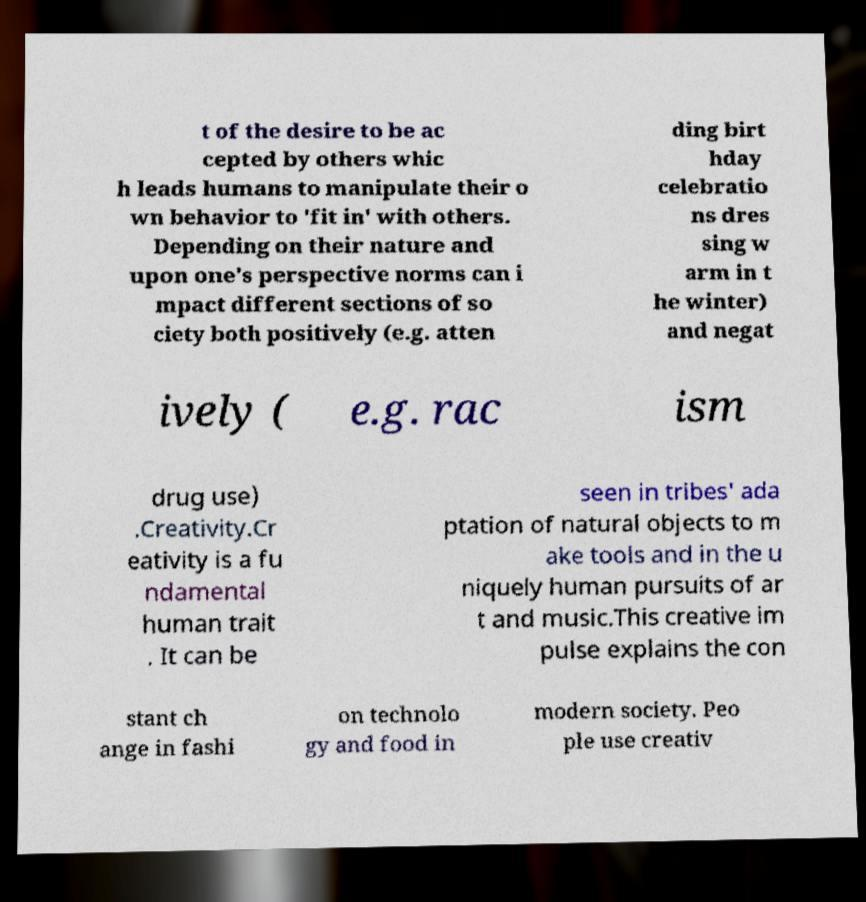There's text embedded in this image that I need extracted. Can you transcribe it verbatim? t of the desire to be ac cepted by others whic h leads humans to manipulate their o wn behavior to 'fit in' with others. Depending on their nature and upon one's perspective norms can i mpact different sections of so ciety both positively (e.g. atten ding birt hday celebratio ns dres sing w arm in t he winter) and negat ively ( e.g. rac ism drug use) .Creativity.Cr eativity is a fu ndamental human trait . It can be seen in tribes' ada ptation of natural objects to m ake tools and in the u niquely human pursuits of ar t and music.This creative im pulse explains the con stant ch ange in fashi on technolo gy and food in modern society. Peo ple use creativ 